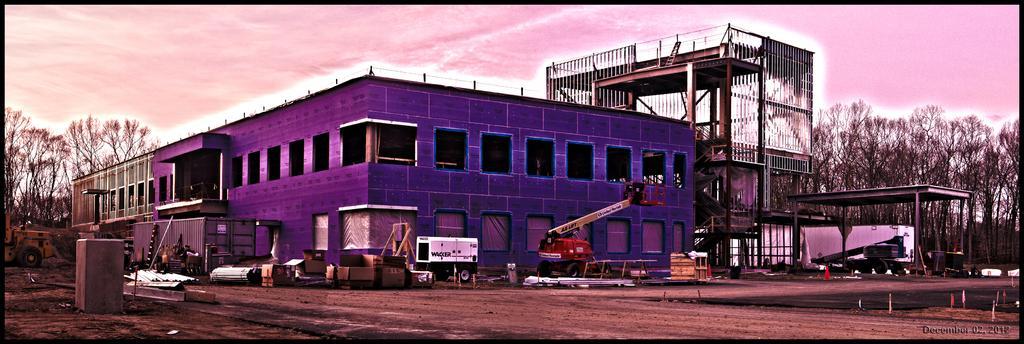Please provide a concise description of this image. In this image in the center there is building in front of the building there cranes and on the right side of the building there is a structure and is a shelter and there are trees. On the left side of the building there are trees and the sky is cloudy. 